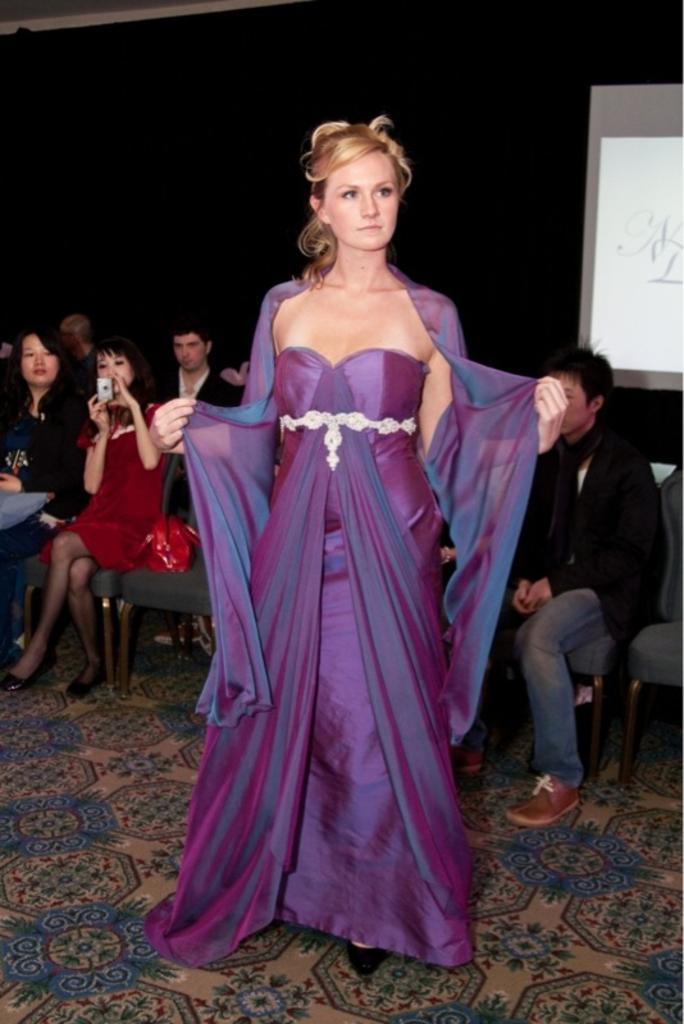Could you give a brief overview of what you see in this image? In this image we can see a group of people sitting on chairs. One woman is holding a camera in her hands. In the foreground of the image we can see a woman standing on the floor. On the right side of the image we can see a screen on the wall. 